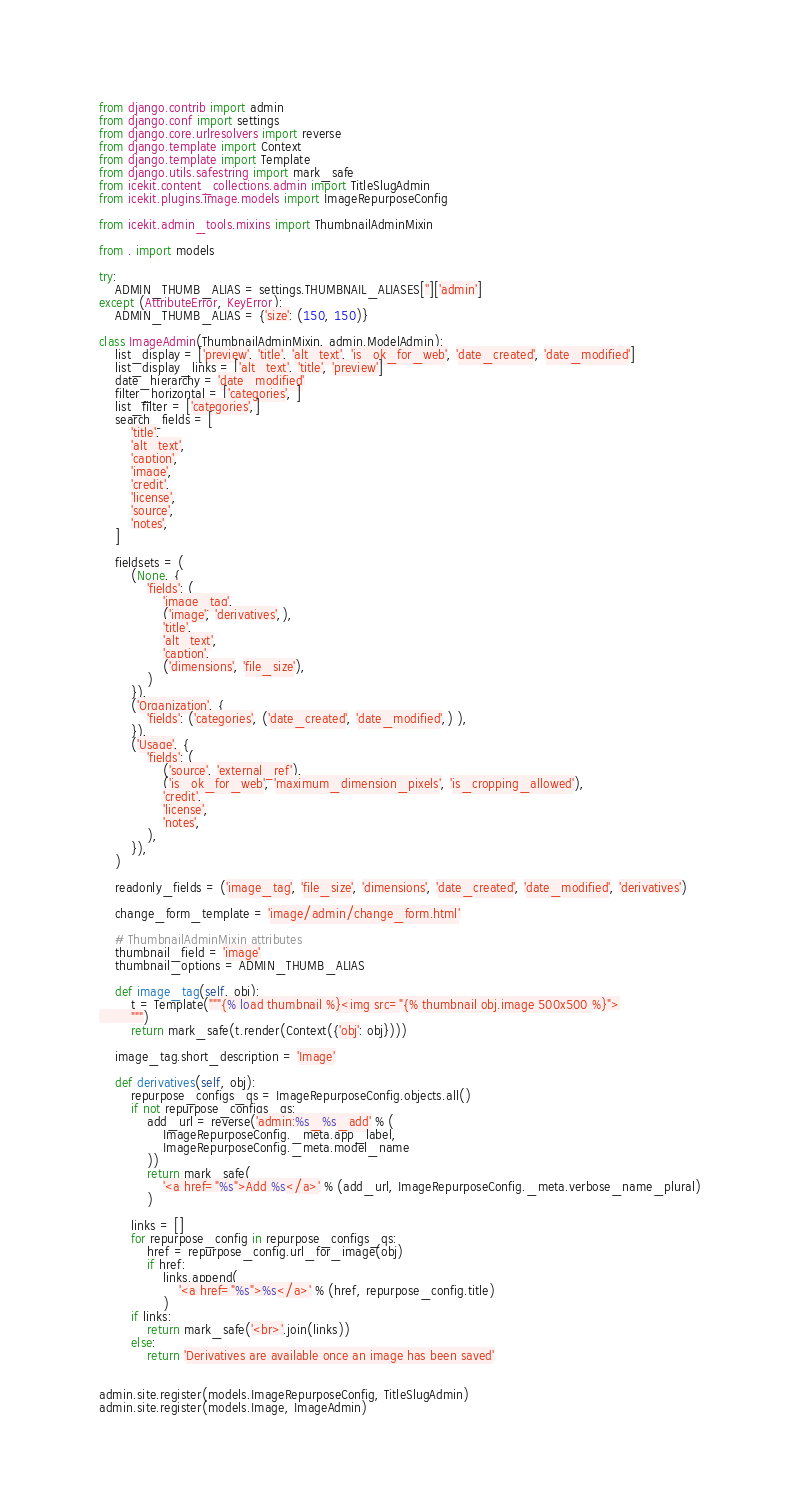<code> <loc_0><loc_0><loc_500><loc_500><_Python_>from django.contrib import admin
from django.conf import settings
from django.core.urlresolvers import reverse
from django.template import Context
from django.template import Template
from django.utils.safestring import mark_safe
from icekit.content_collections.admin import TitleSlugAdmin
from icekit.plugins.image.models import ImageRepurposeConfig

from icekit.admin_tools.mixins import ThumbnailAdminMixin

from . import models

try:
    ADMIN_THUMB_ALIAS = settings.THUMBNAIL_ALIASES['']['admin']
except (AttributeError, KeyError):
    ADMIN_THUMB_ALIAS = {'size': (150, 150)}

class ImageAdmin(ThumbnailAdminMixin, admin.ModelAdmin):
    list_display = ['preview', 'title', 'alt_text', 'is_ok_for_web', 'date_created', 'date_modified']
    list_display_links = ['alt_text', 'title', 'preview']
    date_hierarchy = 'date_modified'
    filter_horizontal = ['categories', ]
    list_filter = ['categories',]
    search_fields = [
        'title',
        'alt_text',
        'caption',
        'image',
        'credit',
        'license',
        'source',
        'notes',
    ]

    fieldsets = (
        (None, {
            'fields': (
                'image_tag',
                ('image', 'derivatives',),
                'title',
                'alt_text',
                'caption',
                ('dimensions', 'file_size'),
            )
        }),
        ('Organization', {
            'fields': ('categories', ('date_created', 'date_modified',) ),
        }),
        ('Usage', {
            'fields': (
                ('source', 'external_ref'),
                ('is_ok_for_web', 'maximum_dimension_pixels', 'is_cropping_allowed'),
                'credit',
                'license',
                'notes',
            ),
        }),
    )

    readonly_fields = ('image_tag', 'file_size', 'dimensions', 'date_created', 'date_modified', 'derivatives')

    change_form_template = 'image/admin/change_form.html'

    # ThumbnailAdminMixin attributes
    thumbnail_field = 'image'
    thumbnail_options = ADMIN_THUMB_ALIAS

    def image_tag(self, obj):
        t = Template("""{% load thumbnail %}<img src="{% thumbnail obj.image 500x500 %}">
        """)
        return mark_safe(t.render(Context({'obj': obj})))

    image_tag.short_description = 'Image'

    def derivatives(self, obj):
        repurpose_configs_qs = ImageRepurposeConfig.objects.all()
        if not repurpose_configs_qs:
            add_url = reverse('admin:%s_%s_add' % (
                ImageRepurposeConfig._meta.app_label,
                ImageRepurposeConfig._meta.model_name
            ))
            return mark_safe(
                '<a href="%s">Add %s</a>' % (add_url, ImageRepurposeConfig._meta.verbose_name_plural)
            )

        links = []
        for repurpose_config in repurpose_configs_qs:
            href = repurpose_config.url_for_image(obj)
            if href:
                links.append(
                    '<a href="%s">%s</a>' % (href, repurpose_config.title)
                )
        if links:
            return mark_safe('<br>'.join(links))
        else:
            return 'Derivatives are available once an image has been saved'


admin.site.register(models.ImageRepurposeConfig, TitleSlugAdmin)
admin.site.register(models.Image, ImageAdmin)
</code> 